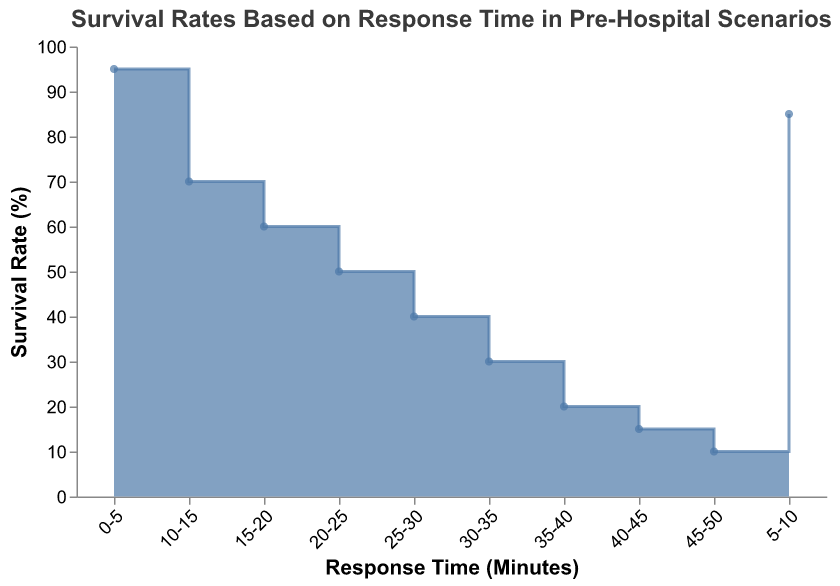What is the title of the figure? The title of the figure is written at the top, providing context to the data presented in the chart. The title reads "Survival Rates Based on Response Time in Pre-Hospital Scenarios."
Answer: Survival Rates Based on Response Time in Pre-Hospital Scenarios How many data points are represented in the figure? By counting the intervals on the x-axis or the number of steps in the area chart, we can see that there are 10 data points.
Answer: 10 Which interval shows the highest survival rate? The highest survival rate can be observed by looking at the y-axis values and identifying the interval with the greatest value. The interval 0-5 minutes has the highest survival rate of 95%.
Answer: 0-5 minutes What is the survival rate for the 25-30 minutes response time interval? To find the survival rate for the 25-30 minutes interval, locate the corresponding interval on the x-axis and refer to the y-axis value. The survival rate is 40%.
Answer: 40% How does the survival rate change from the 10-15 minutes interval to the 15-20 minutes interval? The survival rate for the 10-15 minutes interval is 70%, and for the 15-20 minutes interval, it is 60%. The change is calculated as 70% - 60% = 10%. This indicates a decrease of 10 percentage points.
Answer: Decreases by 10 percentage points What's the difference in survival rates between the intervals 5-10 and 20-25? The survival rate for 5-10 minutes is 85%, and for 20-25 minutes, it's 50%. The difference is found by subtracting the latter from the former: 85% - 50% = 35%.
Answer: 35% Which intervals show survival rates below 50%? Intervals below 50% can be identified by looking at the y-axis values and selecting the corresponding intervals. These intervals are 25-30 minutes, 30-35 minutes, 35-40 minutes, 40-45 minutes, and 45-50 minutes.
Answer: 25-30, 30-35, 35-40, 40-45, 45-50 At which interval does the survival rate first drop below 60%? To determine the first interval where the survival rate drops below 60%, look at the y-axis values in descending order. The interval 20-25 minutes, with a survival rate of 50%, is the first to drop below 60%.
Answer: 20-25 minutes What is the total decrease in survival rate from the 0-5 minutes interval to the 45-50 minutes interval? The survival rate for 0-5 minutes is 95%, and for 45-50 minutes, it is 10%. The total decrease is calculated as 95% - 10% = 85%.
Answer: 85% 